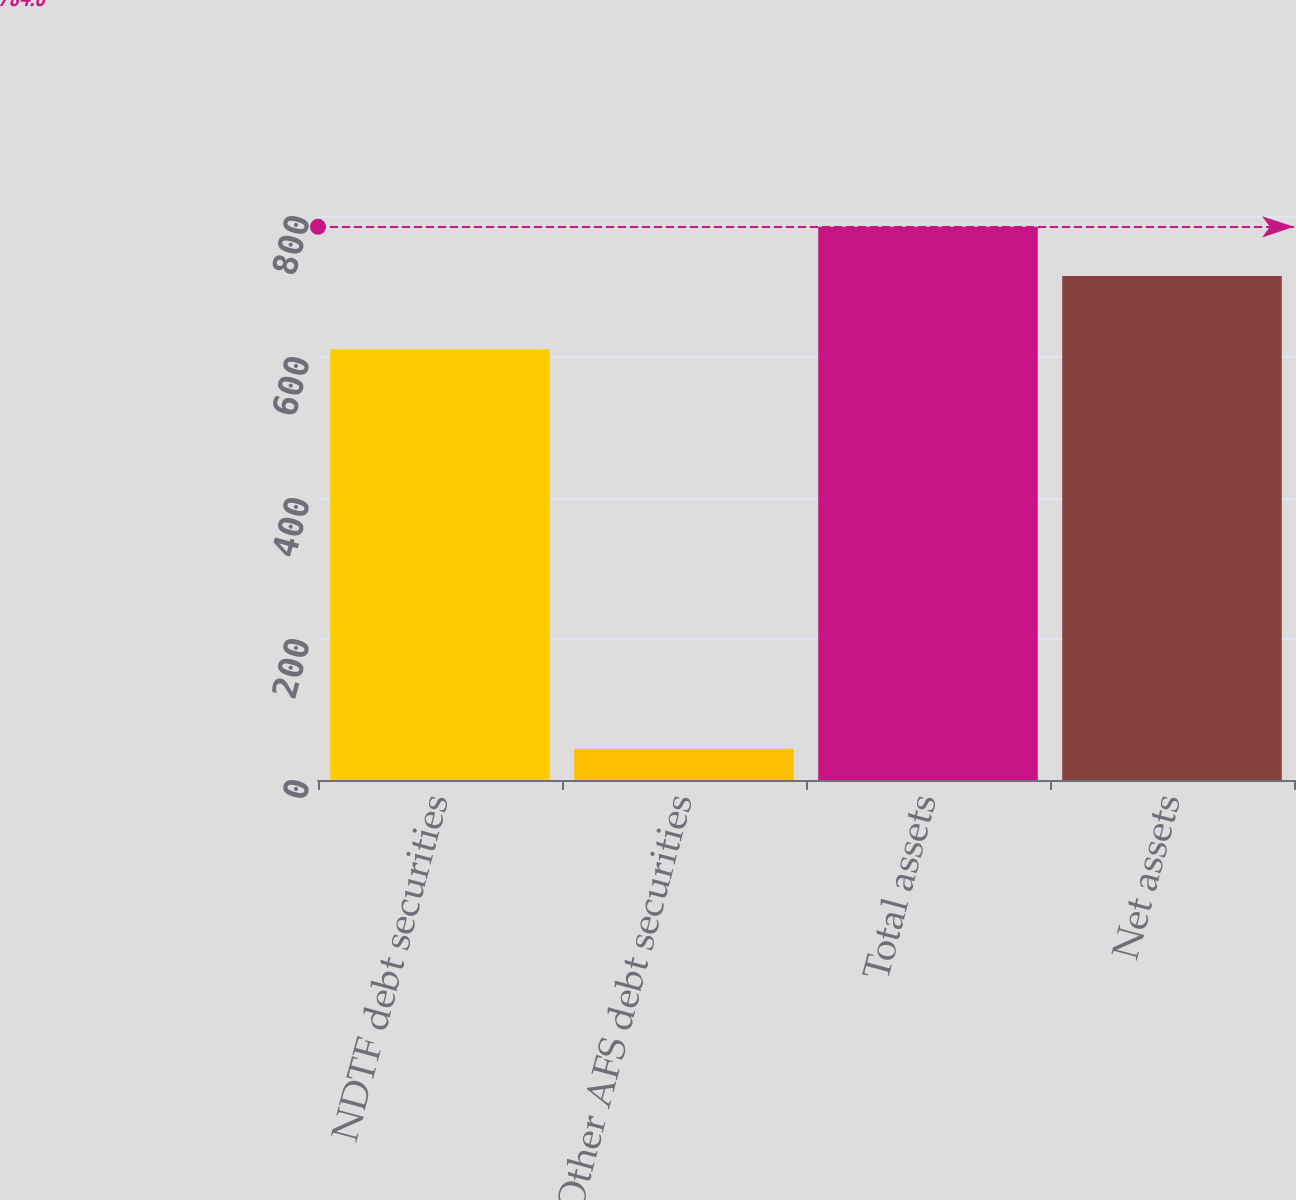Convert chart. <chart><loc_0><loc_0><loc_500><loc_500><bar_chart><fcel>NDTF debt securities<fcel>Other AFS debt securities<fcel>Total assets<fcel>Net assets<nl><fcel>611<fcel>44<fcel>784.6<fcel>715<nl></chart> 